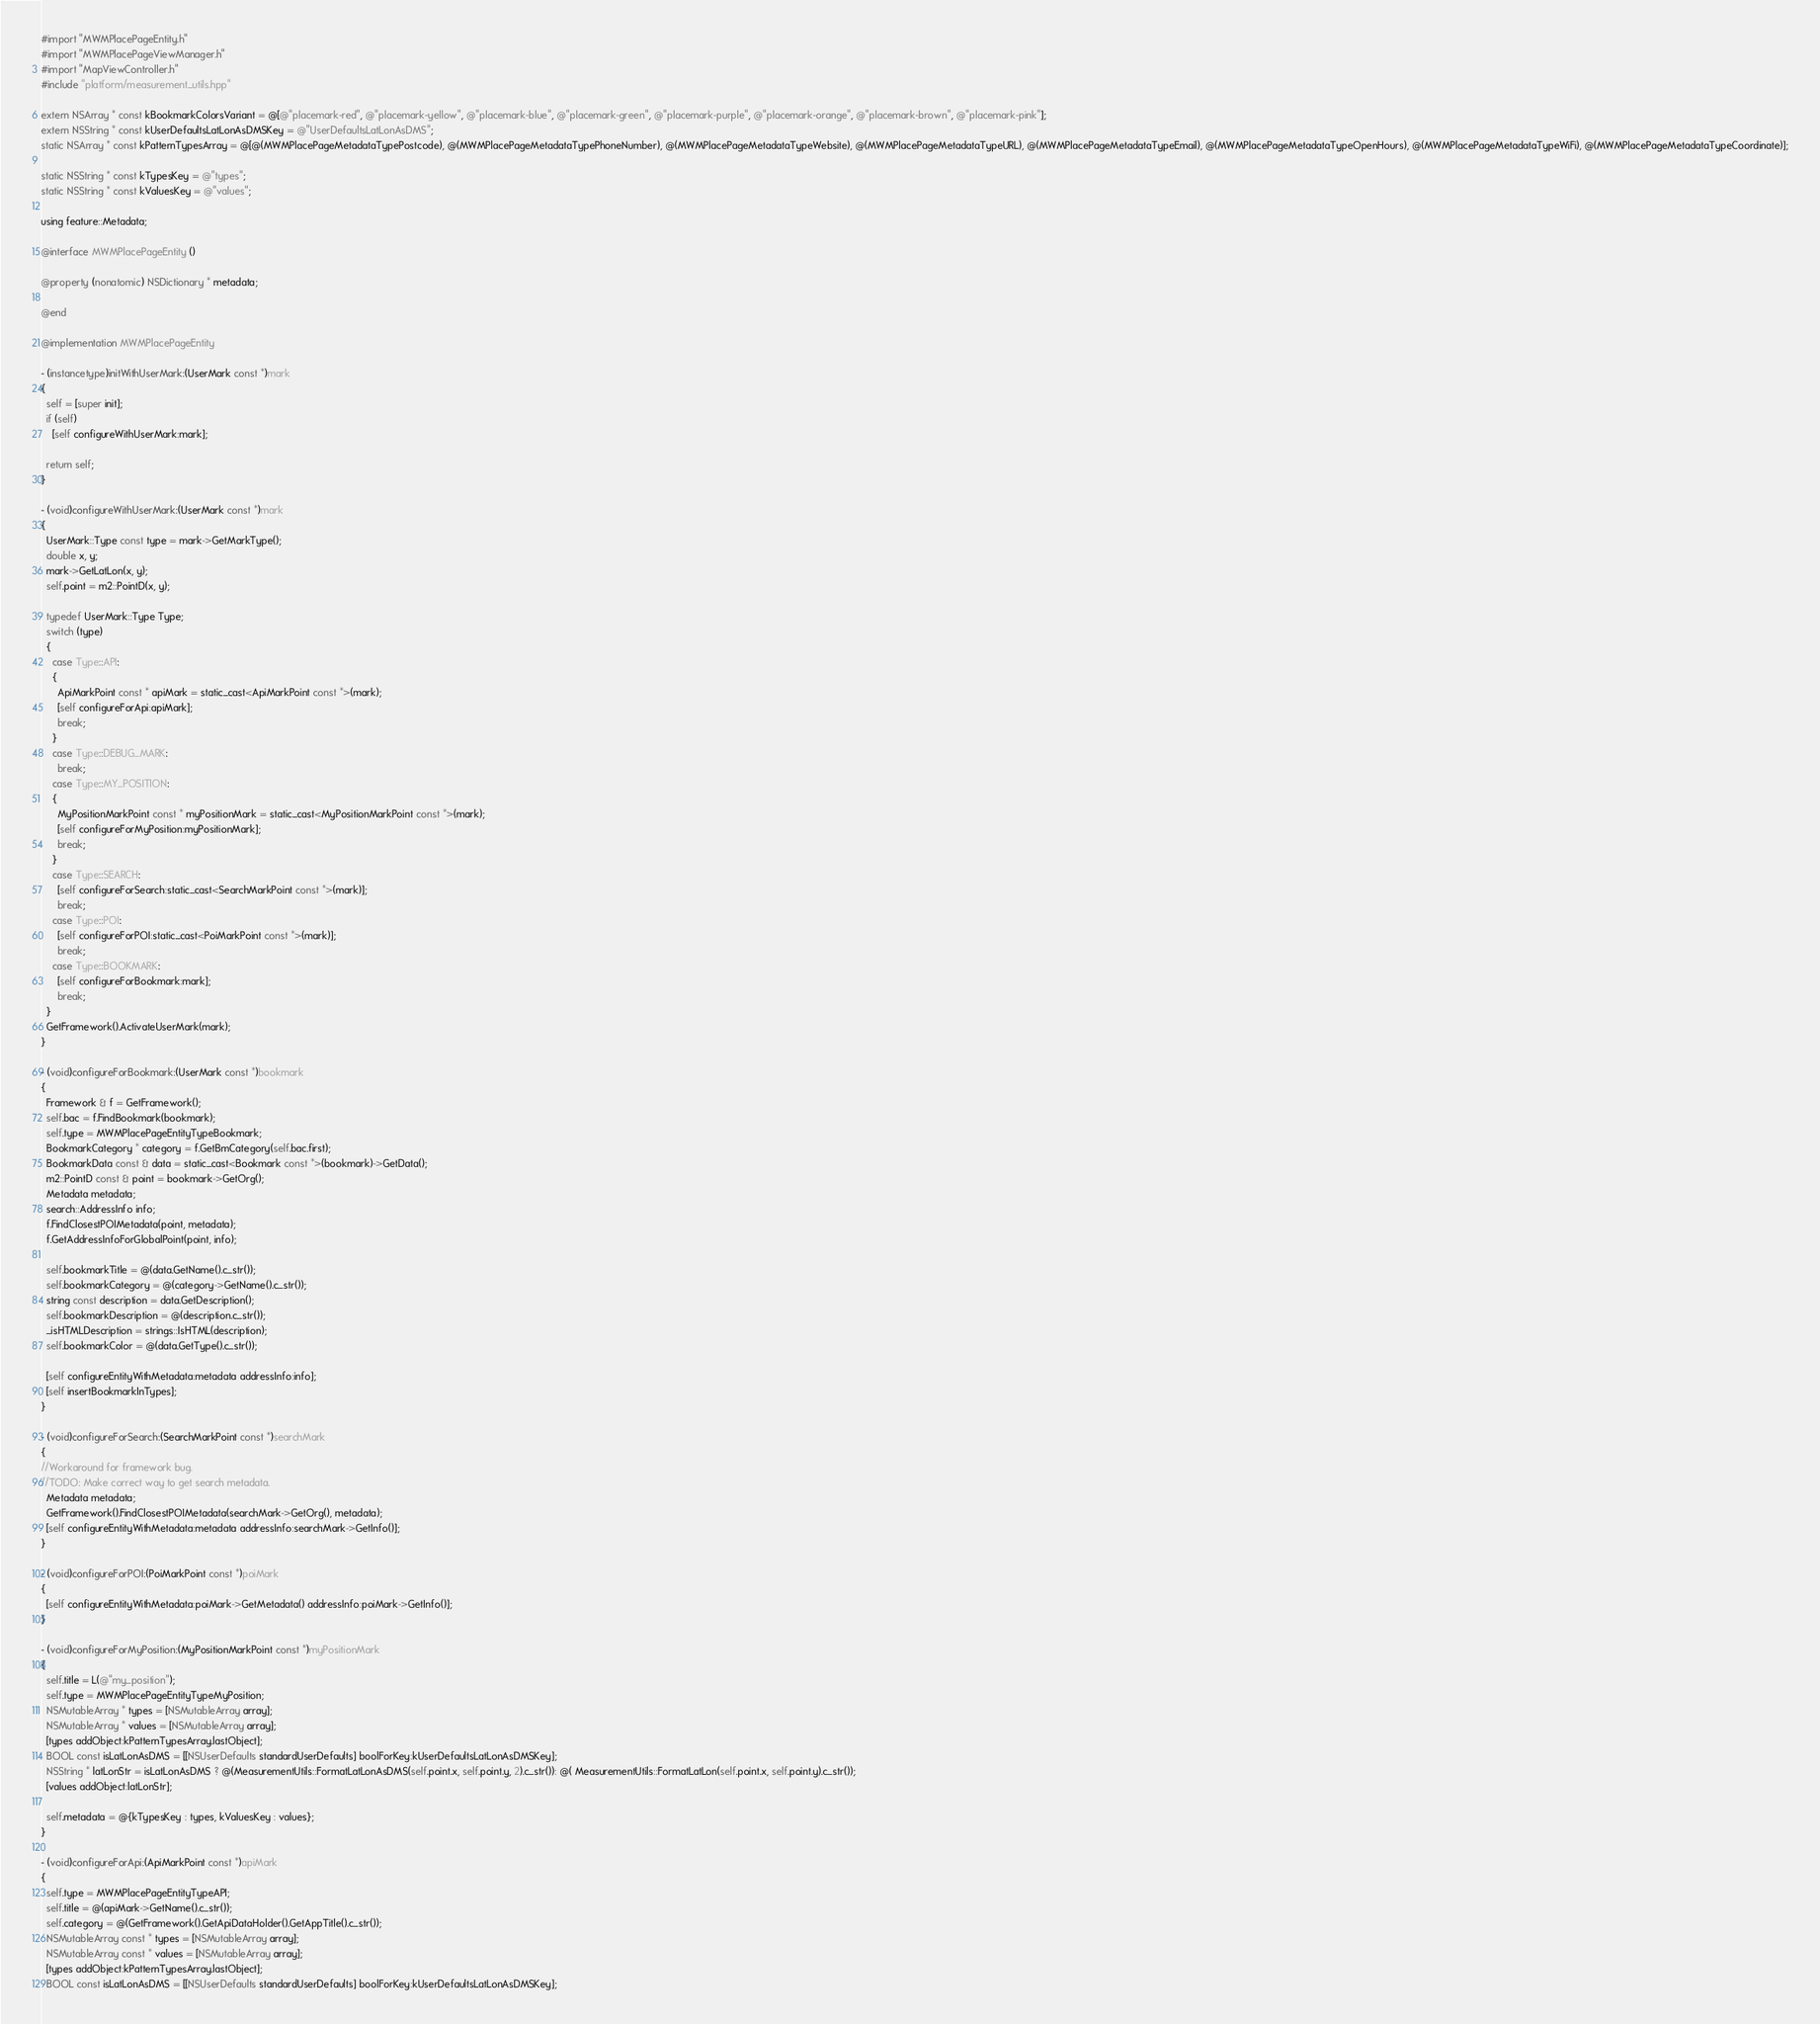Convert code to text. <code><loc_0><loc_0><loc_500><loc_500><_ObjectiveC_>#import "MWMPlacePageEntity.h"
#import "MWMPlacePageViewManager.h"
#import "MapViewController.h"
#include "platform/measurement_utils.hpp"

extern NSArray * const kBookmarkColorsVariant = @[@"placemark-red", @"placemark-yellow", @"placemark-blue", @"placemark-green", @"placemark-purple", @"placemark-orange", @"placemark-brown", @"placemark-pink"];
extern NSString * const kUserDefaultsLatLonAsDMSKey = @"UserDefaultsLatLonAsDMS";
static NSArray * const kPatternTypesArray = @[@(MWMPlacePageMetadataTypePostcode), @(MWMPlacePageMetadataTypePhoneNumber), @(MWMPlacePageMetadataTypeWebsite), @(MWMPlacePageMetadataTypeURL), @(MWMPlacePageMetadataTypeEmail), @(MWMPlacePageMetadataTypeOpenHours), @(MWMPlacePageMetadataTypeWiFi), @(MWMPlacePageMetadataTypeCoordinate)];

static NSString * const kTypesKey = @"types";
static NSString * const kValuesKey = @"values";

using feature::Metadata;

@interface MWMPlacePageEntity ()

@property (nonatomic) NSDictionary * metadata;

@end

@implementation MWMPlacePageEntity

- (instancetype)initWithUserMark:(UserMark const *)mark
{
  self = [super init];
  if (self)
    [self configureWithUserMark:mark];

  return self;
}

- (void)configureWithUserMark:(UserMark const *)mark
{
  UserMark::Type const type = mark->GetMarkType();
  double x, y;
  mark->GetLatLon(x, y);
  self.point = m2::PointD(x, y);

  typedef UserMark::Type Type;
  switch (type)
  {
    case Type::API:
    {
      ApiMarkPoint const * apiMark = static_cast<ApiMarkPoint const *>(mark);
      [self configureForApi:apiMark];
      break;
    }
    case Type::DEBUG_MARK:
      break;
    case Type::MY_POSITION:
    {
      MyPositionMarkPoint const * myPositionMark = static_cast<MyPositionMarkPoint const *>(mark);
      [self configureForMyPosition:myPositionMark];
      break;
    }
    case Type::SEARCH:
      [self configureForSearch:static_cast<SearchMarkPoint const *>(mark)];
      break;
    case Type::POI:
      [self configureForPOI:static_cast<PoiMarkPoint const *>(mark)];
      break;
    case Type::BOOKMARK:
      [self configureForBookmark:mark];
      break;
  }
  GetFramework().ActivateUserMark(mark);
}

- (void)configureForBookmark:(UserMark const *)bookmark
{
  Framework & f = GetFramework();
  self.bac = f.FindBookmark(bookmark);
  self.type = MWMPlacePageEntityTypeBookmark;
  BookmarkCategory * category = f.GetBmCategory(self.bac.first);
  BookmarkData const & data = static_cast<Bookmark const *>(bookmark)->GetData();
  m2::PointD const & point = bookmark->GetOrg();
  Metadata metadata;
  search::AddressInfo info;
  f.FindClosestPOIMetadata(point, metadata);
  f.GetAddressInfoForGlobalPoint(point, info);

  self.bookmarkTitle = @(data.GetName().c_str());
  self.bookmarkCategory = @(category->GetName().c_str());
  string const description = data.GetDescription();
  self.bookmarkDescription = @(description.c_str());
  _isHTMLDescription = strings::IsHTML(description);
  self.bookmarkColor = @(data.GetType().c_str());

  [self configureEntityWithMetadata:metadata addressInfo:info];
  [self insertBookmarkInTypes];
}

- (void)configureForSearch:(SearchMarkPoint const *)searchMark
{
//Workaround for framework bug.
//TODO: Make correct way to get search metadata.
  Metadata metadata;
  GetFramework().FindClosestPOIMetadata(searchMark->GetOrg(), metadata);
  [self configureEntityWithMetadata:metadata addressInfo:searchMark->GetInfo()];
}

- (void)configureForPOI:(PoiMarkPoint const *)poiMark
{
  [self configureEntityWithMetadata:poiMark->GetMetadata() addressInfo:poiMark->GetInfo()];
}

- (void)configureForMyPosition:(MyPositionMarkPoint const *)myPositionMark
{
  self.title = L(@"my_position");
  self.type = MWMPlacePageEntityTypeMyPosition;
  NSMutableArray * types = [NSMutableArray array];
  NSMutableArray * values = [NSMutableArray array];
  [types addObject:kPatternTypesArray.lastObject];
  BOOL const isLatLonAsDMS = [[NSUserDefaults standardUserDefaults] boolForKey:kUserDefaultsLatLonAsDMSKey];
  NSString * latLonStr = isLatLonAsDMS ? @(MeasurementUtils::FormatLatLonAsDMS(self.point.x, self.point.y, 2).c_str()): @( MeasurementUtils::FormatLatLon(self.point.x, self.point.y).c_str());
  [values addObject:latLonStr];

  self.metadata = @{kTypesKey : types, kValuesKey : values};
}

- (void)configureForApi:(ApiMarkPoint const *)apiMark
{
  self.type = MWMPlacePageEntityTypeAPI;
  self.title = @(apiMark->GetName().c_str());
  self.category = @(GetFramework().GetApiDataHolder().GetAppTitle().c_str());
  NSMutableArray const * types = [NSMutableArray array];
  NSMutableArray const * values = [NSMutableArray array];
  [types addObject:kPatternTypesArray.lastObject];
  BOOL const isLatLonAsDMS = [[NSUserDefaults standardUserDefaults] boolForKey:kUserDefaultsLatLonAsDMSKey];</code> 